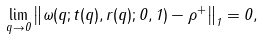Convert formula to latex. <formula><loc_0><loc_0><loc_500><loc_500>\lim _ { q \rightarrow 0 } \left \| \omega ( q ; t ( q ) , r ( q ) ; 0 , 1 ) - \rho ^ { + } \right \| _ { 1 } = 0 ,</formula> 